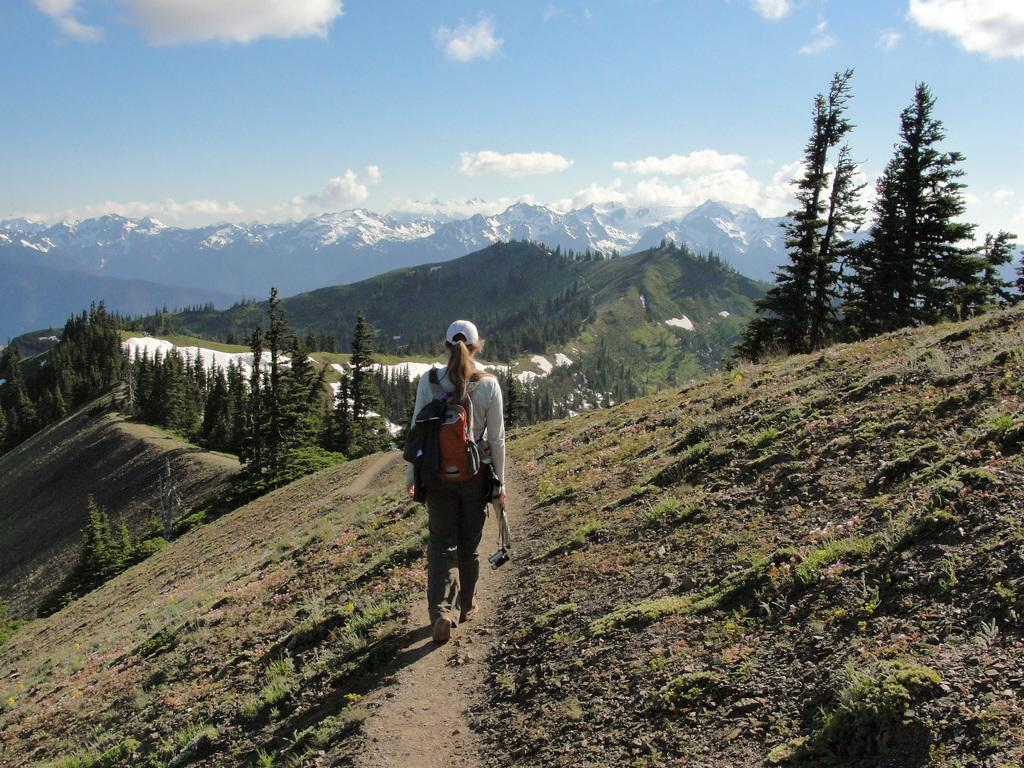What is the person in the image doing? The person is walking in the image. What is the person wearing on their body? The person is wearing a bag and a cap. What type of terrain is visible in the image? There is grass visible in the image, and there are hills in the background. What is the weather like in the image? The presence of snow and clouds in the background suggests that it is a cold and possibly snowy day. What is visible in the sky? The sky is visible in the background of the image, and there are clouds present. What type of beam is holding up the actor in the image? There is no actor or beam present in the image; it features a person walking in an outdoor setting with snowy hills and a cloudy sky. 